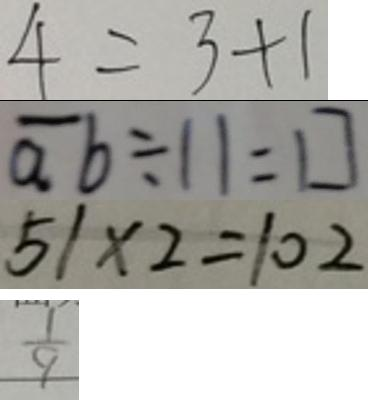<formula> <loc_0><loc_0><loc_500><loc_500>4 = 3 + 1 
 \overline { a } b \div 1 1 = \square 
 5 1 \times 2 = 1 0 2 
 \frac { 1 } { 9 }</formula> 